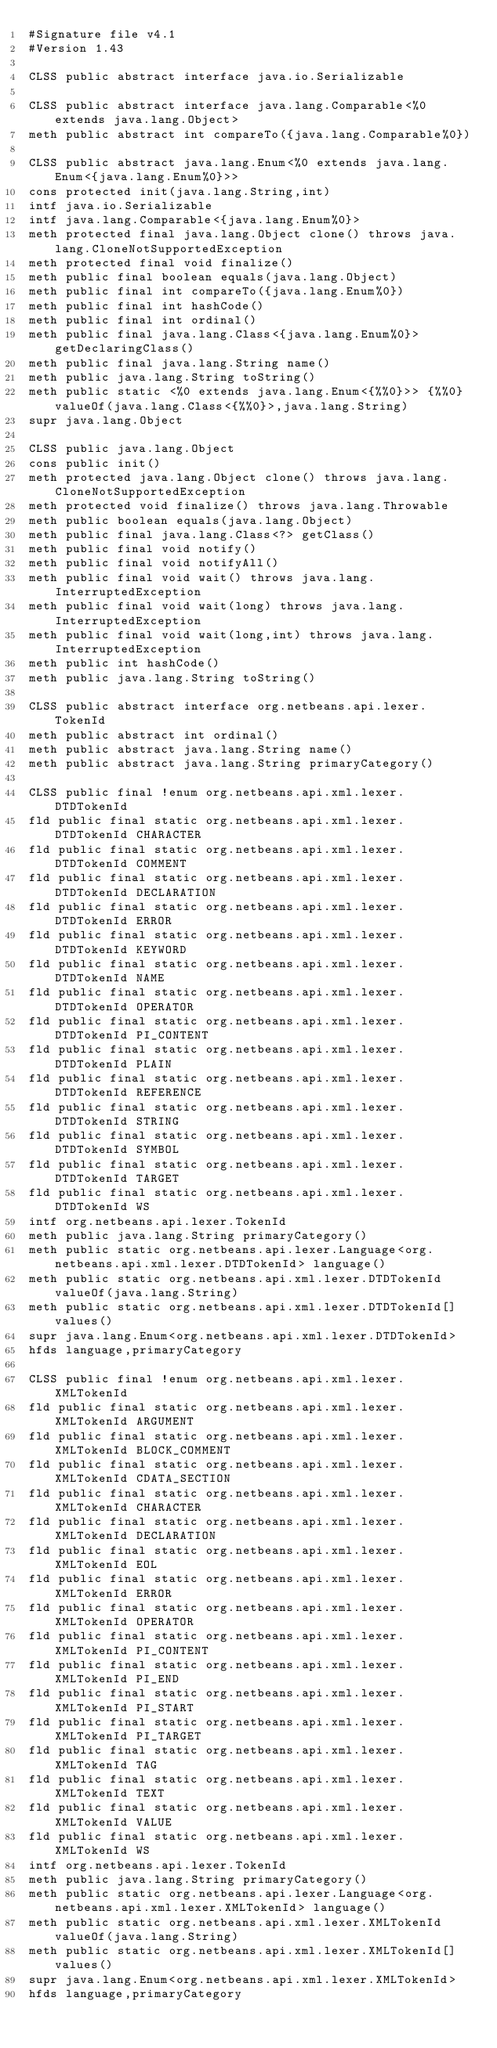<code> <loc_0><loc_0><loc_500><loc_500><_SML_>#Signature file v4.1
#Version 1.43

CLSS public abstract interface java.io.Serializable

CLSS public abstract interface java.lang.Comparable<%0 extends java.lang.Object>
meth public abstract int compareTo({java.lang.Comparable%0})

CLSS public abstract java.lang.Enum<%0 extends java.lang.Enum<{java.lang.Enum%0}>>
cons protected init(java.lang.String,int)
intf java.io.Serializable
intf java.lang.Comparable<{java.lang.Enum%0}>
meth protected final java.lang.Object clone() throws java.lang.CloneNotSupportedException
meth protected final void finalize()
meth public final boolean equals(java.lang.Object)
meth public final int compareTo({java.lang.Enum%0})
meth public final int hashCode()
meth public final int ordinal()
meth public final java.lang.Class<{java.lang.Enum%0}> getDeclaringClass()
meth public final java.lang.String name()
meth public java.lang.String toString()
meth public static <%0 extends java.lang.Enum<{%%0}>> {%%0} valueOf(java.lang.Class<{%%0}>,java.lang.String)
supr java.lang.Object

CLSS public java.lang.Object
cons public init()
meth protected java.lang.Object clone() throws java.lang.CloneNotSupportedException
meth protected void finalize() throws java.lang.Throwable
meth public boolean equals(java.lang.Object)
meth public final java.lang.Class<?> getClass()
meth public final void notify()
meth public final void notifyAll()
meth public final void wait() throws java.lang.InterruptedException
meth public final void wait(long) throws java.lang.InterruptedException
meth public final void wait(long,int) throws java.lang.InterruptedException
meth public int hashCode()
meth public java.lang.String toString()

CLSS public abstract interface org.netbeans.api.lexer.TokenId
meth public abstract int ordinal()
meth public abstract java.lang.String name()
meth public abstract java.lang.String primaryCategory()

CLSS public final !enum org.netbeans.api.xml.lexer.DTDTokenId
fld public final static org.netbeans.api.xml.lexer.DTDTokenId CHARACTER
fld public final static org.netbeans.api.xml.lexer.DTDTokenId COMMENT
fld public final static org.netbeans.api.xml.lexer.DTDTokenId DECLARATION
fld public final static org.netbeans.api.xml.lexer.DTDTokenId ERROR
fld public final static org.netbeans.api.xml.lexer.DTDTokenId KEYWORD
fld public final static org.netbeans.api.xml.lexer.DTDTokenId NAME
fld public final static org.netbeans.api.xml.lexer.DTDTokenId OPERATOR
fld public final static org.netbeans.api.xml.lexer.DTDTokenId PI_CONTENT
fld public final static org.netbeans.api.xml.lexer.DTDTokenId PLAIN
fld public final static org.netbeans.api.xml.lexer.DTDTokenId REFERENCE
fld public final static org.netbeans.api.xml.lexer.DTDTokenId STRING
fld public final static org.netbeans.api.xml.lexer.DTDTokenId SYMBOL
fld public final static org.netbeans.api.xml.lexer.DTDTokenId TARGET
fld public final static org.netbeans.api.xml.lexer.DTDTokenId WS
intf org.netbeans.api.lexer.TokenId
meth public java.lang.String primaryCategory()
meth public static org.netbeans.api.lexer.Language<org.netbeans.api.xml.lexer.DTDTokenId> language()
meth public static org.netbeans.api.xml.lexer.DTDTokenId valueOf(java.lang.String)
meth public static org.netbeans.api.xml.lexer.DTDTokenId[] values()
supr java.lang.Enum<org.netbeans.api.xml.lexer.DTDTokenId>
hfds language,primaryCategory

CLSS public final !enum org.netbeans.api.xml.lexer.XMLTokenId
fld public final static org.netbeans.api.xml.lexer.XMLTokenId ARGUMENT
fld public final static org.netbeans.api.xml.lexer.XMLTokenId BLOCK_COMMENT
fld public final static org.netbeans.api.xml.lexer.XMLTokenId CDATA_SECTION
fld public final static org.netbeans.api.xml.lexer.XMLTokenId CHARACTER
fld public final static org.netbeans.api.xml.lexer.XMLTokenId DECLARATION
fld public final static org.netbeans.api.xml.lexer.XMLTokenId EOL
fld public final static org.netbeans.api.xml.lexer.XMLTokenId ERROR
fld public final static org.netbeans.api.xml.lexer.XMLTokenId OPERATOR
fld public final static org.netbeans.api.xml.lexer.XMLTokenId PI_CONTENT
fld public final static org.netbeans.api.xml.lexer.XMLTokenId PI_END
fld public final static org.netbeans.api.xml.lexer.XMLTokenId PI_START
fld public final static org.netbeans.api.xml.lexer.XMLTokenId PI_TARGET
fld public final static org.netbeans.api.xml.lexer.XMLTokenId TAG
fld public final static org.netbeans.api.xml.lexer.XMLTokenId TEXT
fld public final static org.netbeans.api.xml.lexer.XMLTokenId VALUE
fld public final static org.netbeans.api.xml.lexer.XMLTokenId WS
intf org.netbeans.api.lexer.TokenId
meth public java.lang.String primaryCategory()
meth public static org.netbeans.api.lexer.Language<org.netbeans.api.xml.lexer.XMLTokenId> language()
meth public static org.netbeans.api.xml.lexer.XMLTokenId valueOf(java.lang.String)
meth public static org.netbeans.api.xml.lexer.XMLTokenId[] values()
supr java.lang.Enum<org.netbeans.api.xml.lexer.XMLTokenId>
hfds language,primaryCategory

</code> 